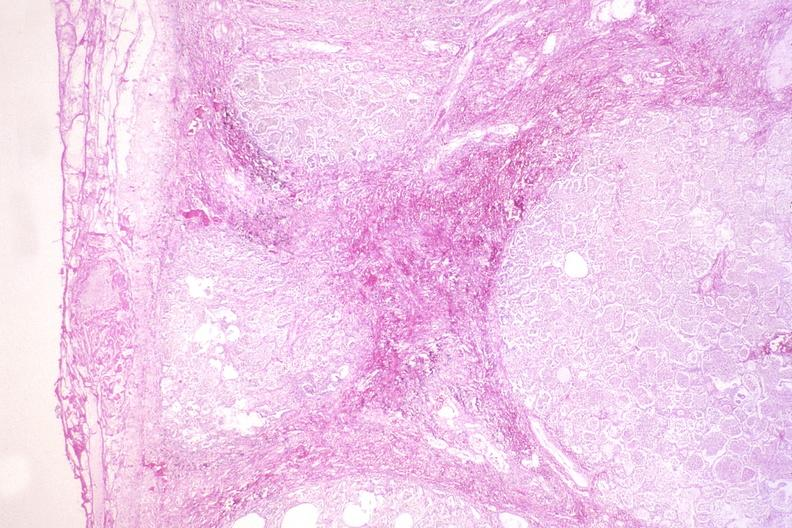s respiratory present?
Answer the question using a single word or phrase. Yes 